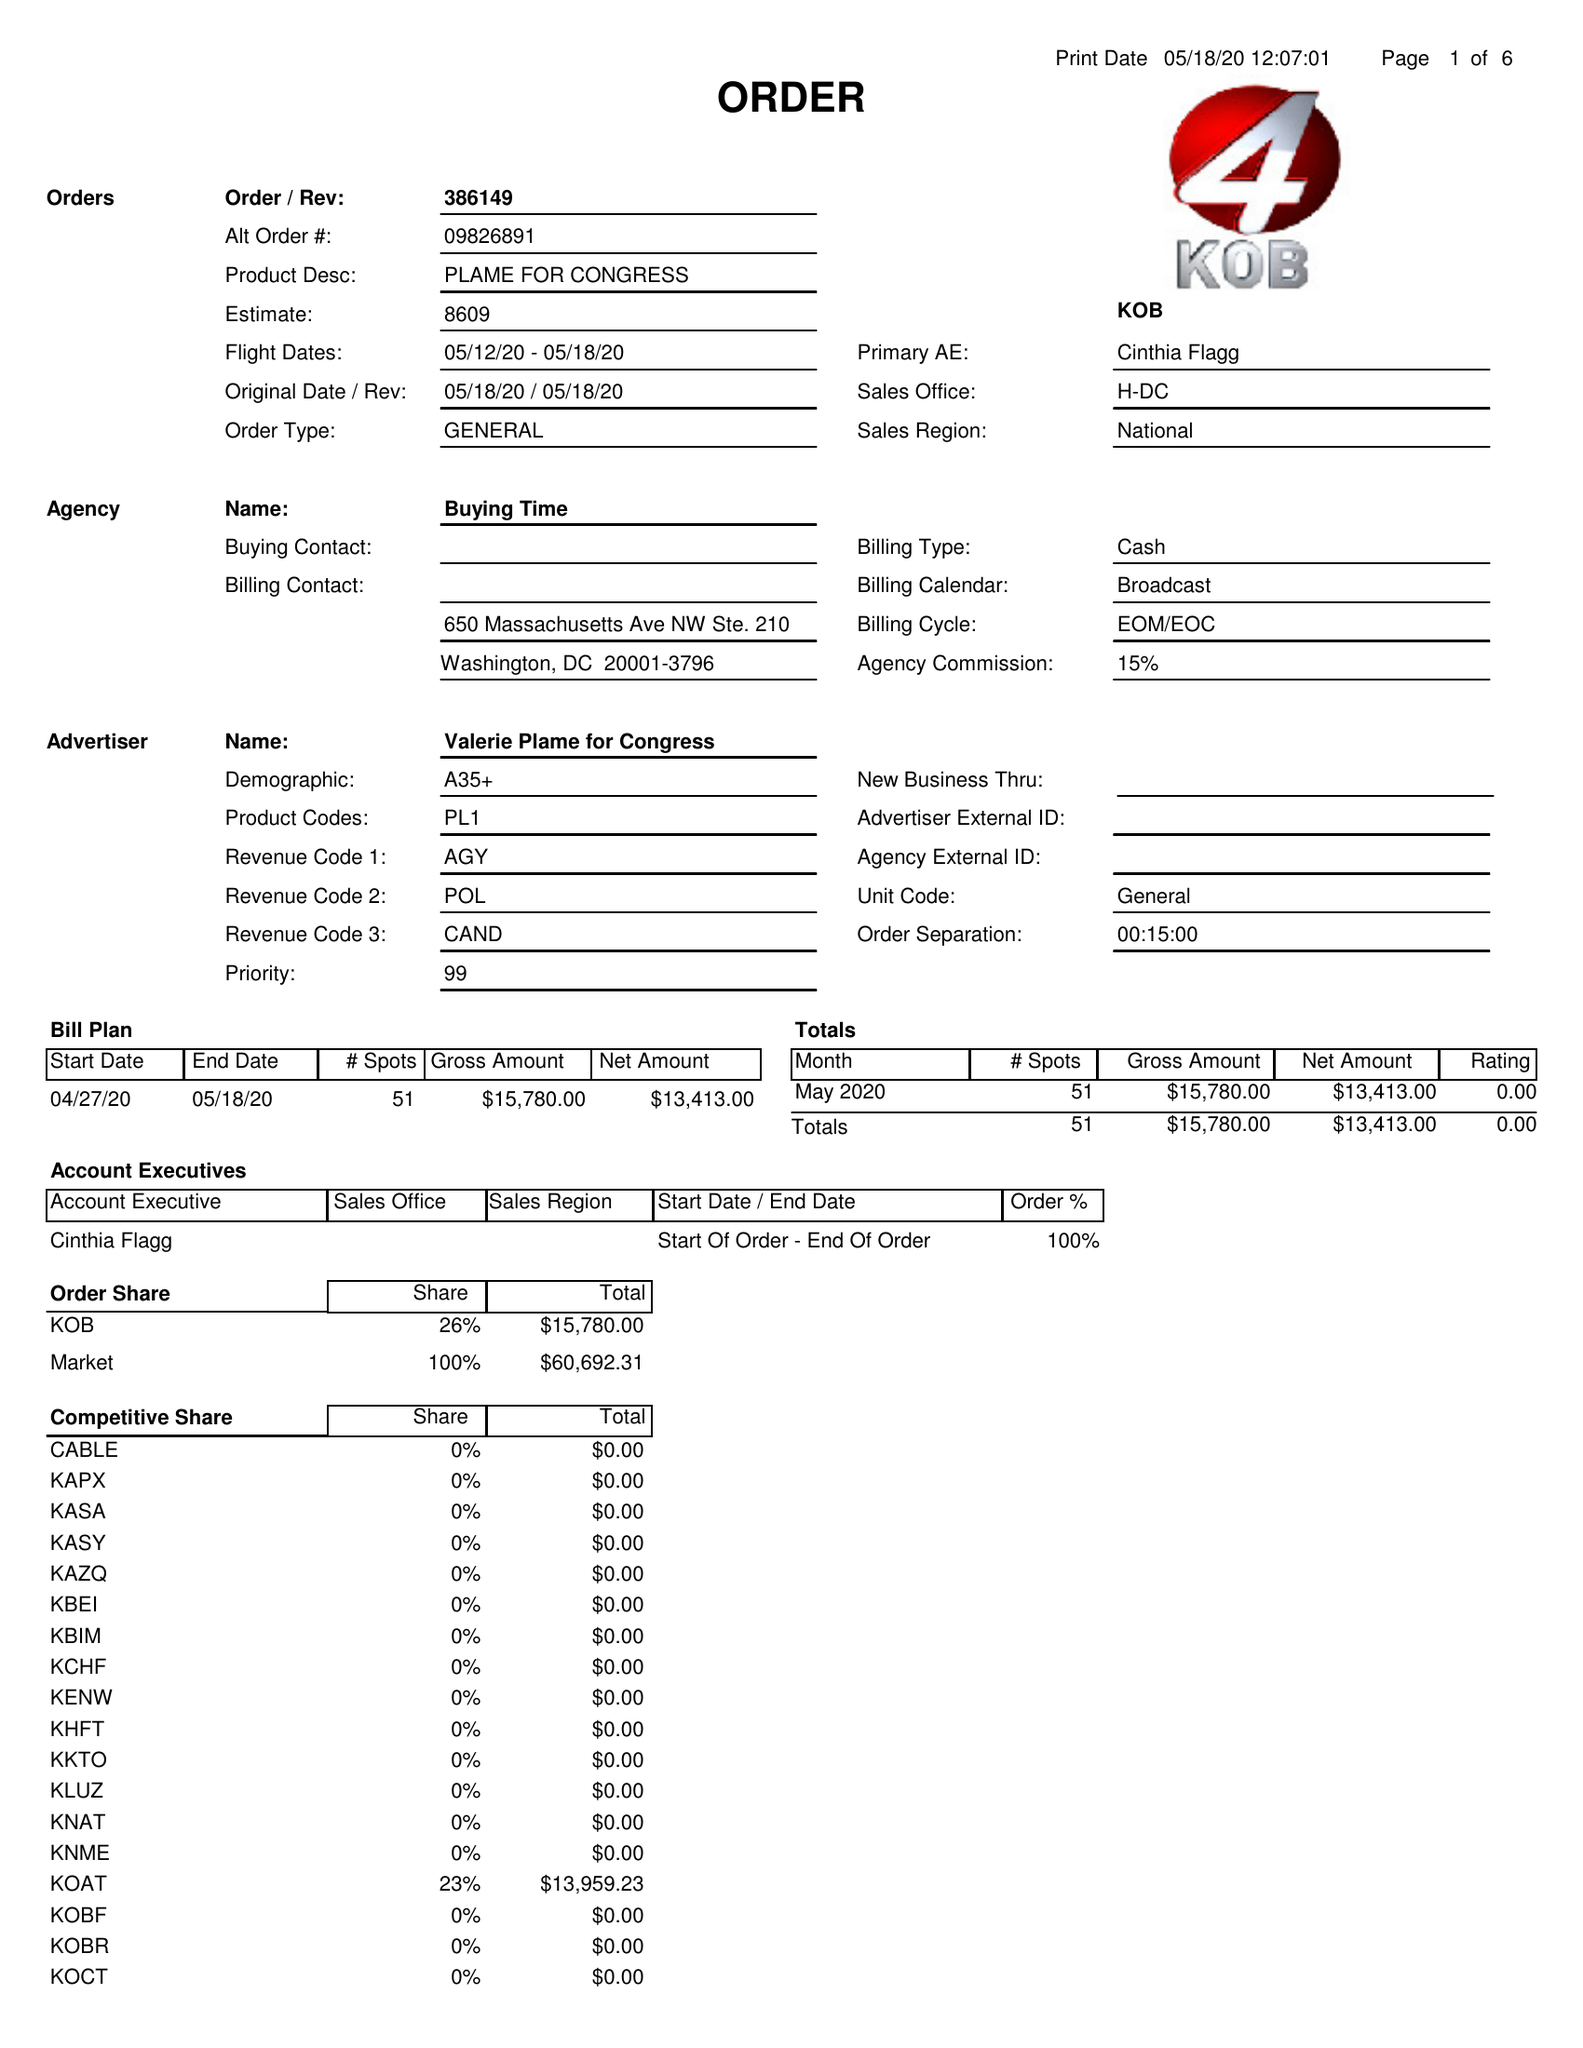What is the value for the flight_from?
Answer the question using a single word or phrase. 05/12/20 